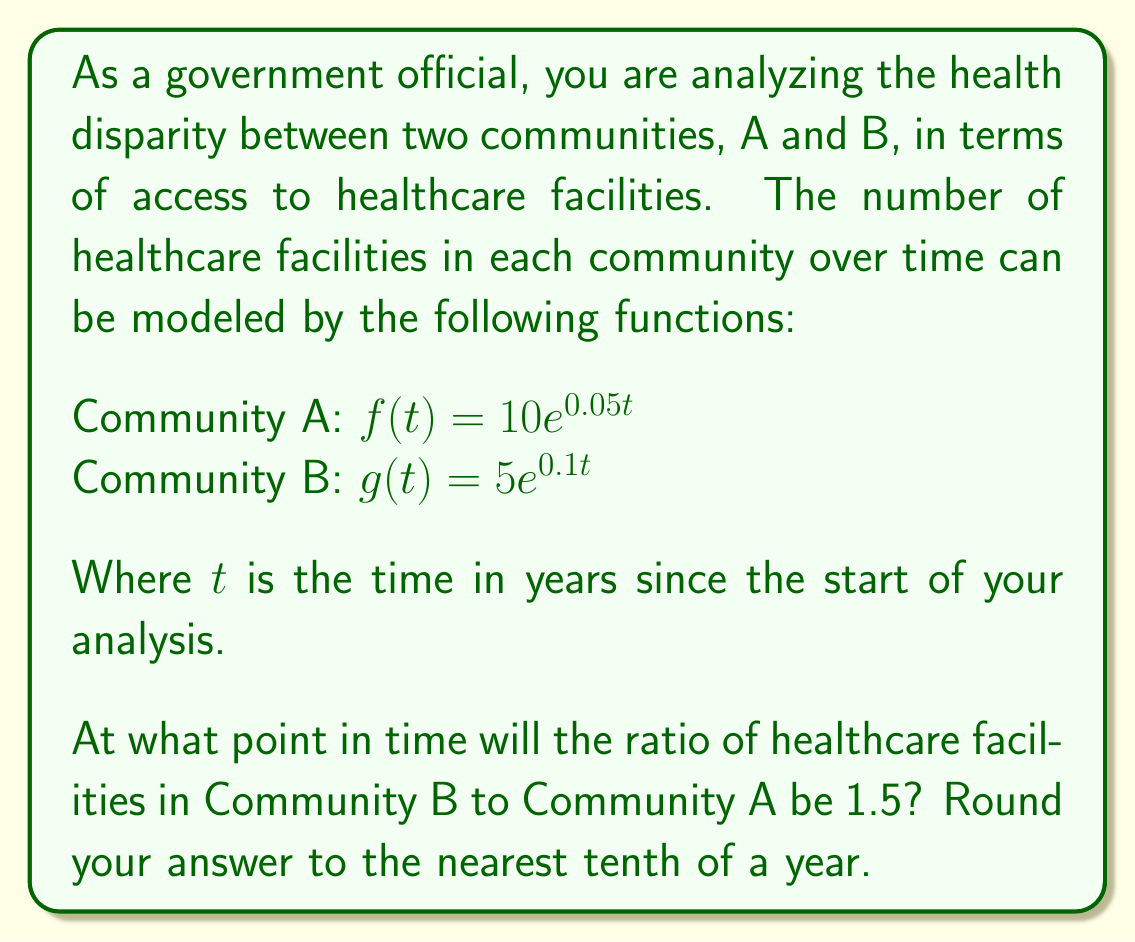Could you help me with this problem? To solve this problem, we need to follow these steps:

1) We want to find $t$ when $\frac{g(t)}{f(t)} = 1.5$

2) Let's set up the equation:

   $$\frac{g(t)}{f(t)} = 1.5$$

3) Substitute the functions:

   $$\frac{5e^{0.1t}}{10e^{0.05t}} = 1.5$$

4) Simplify:

   $$0.5e^{0.05t} = 1.5$$

5) Multiply both sides by 2:

   $$e^{0.05t} = 3$$

6) Take the natural log of both sides:

   $$\ln(e^{0.05t}) = \ln(3)$$

7) Simplify the left side:

   $$0.05t = \ln(3)$$

8) Divide both sides by 0.05:

   $$t = \frac{\ln(3)}{0.05}$$

9) Calculate:

   $$t \approx 21.9720...$$

10) Rounding to the nearest tenth:

    $$t \approx 22.0$$

Therefore, the ratio of healthcare facilities in Community B to Community A will be 1.5 after approximately 22.0 years.
Answer: 22.0 years 